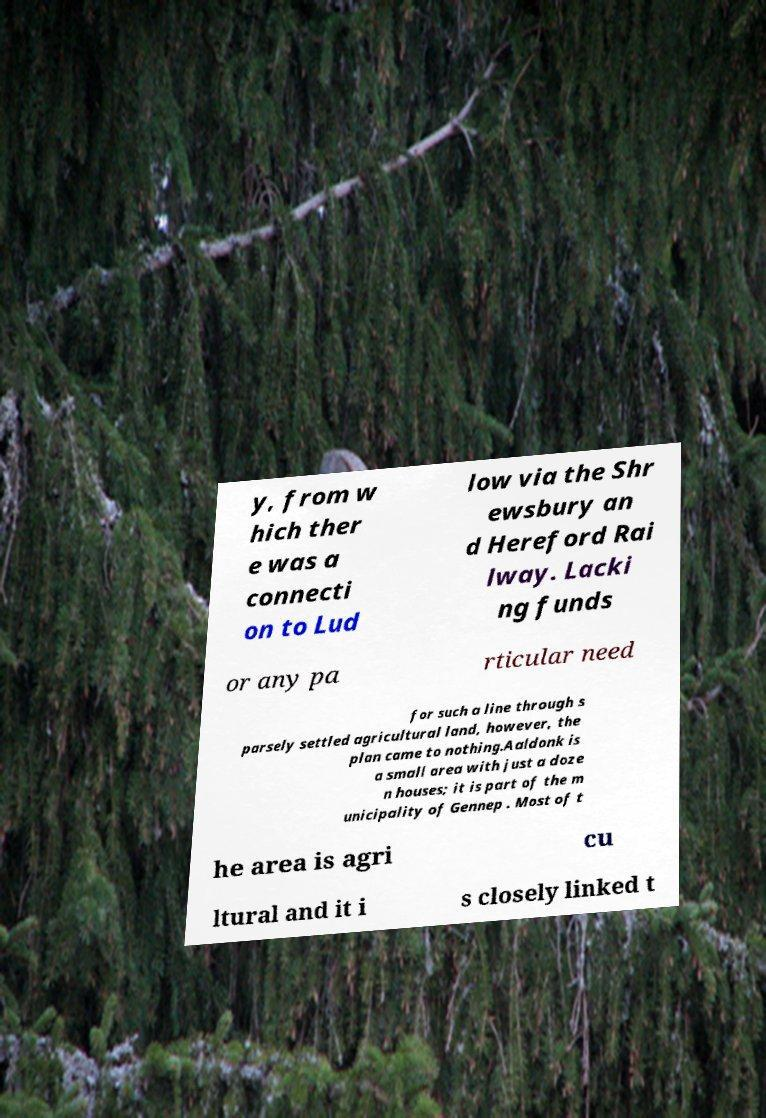Please read and relay the text visible in this image. What does it say? y, from w hich ther e was a connecti on to Lud low via the Shr ewsbury an d Hereford Rai lway. Lacki ng funds or any pa rticular need for such a line through s parsely settled agricultural land, however, the plan came to nothing.Aaldonk is a small area with just a doze n houses; it is part of the m unicipality of Gennep . Most of t he area is agri cu ltural and it i s closely linked t 